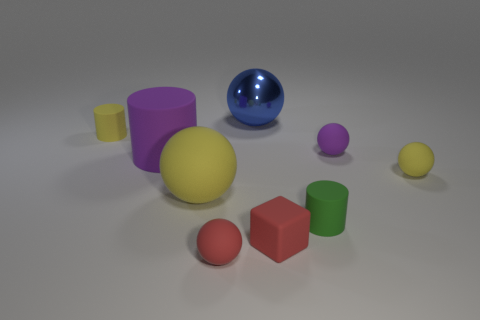There is a red cube that is made of the same material as the yellow cylinder; what size is it?
Offer a very short reply. Small. What is the size of the thing that is left of the small purple rubber sphere and to the right of the tiny red matte block?
Your response must be concise. Small. How big is the yellow rubber sphere behind the yellow matte sphere that is in front of the tiny yellow thing that is right of the green cylinder?
Your answer should be very brief. Small. Does the small matte sphere that is behind the big purple rubber thing have the same color as the large cylinder?
Make the answer very short. Yes. How many things are either purple things or yellow matte cylinders?
Offer a very short reply. 3. What is the color of the small cylinder that is on the left side of the small red sphere?
Offer a very short reply. Yellow. Is the number of purple matte things that are left of the small red matte ball less than the number of large yellow matte things?
Your answer should be very brief. No. The object that is the same color as the matte block is what size?
Your answer should be compact. Small. Is there anything else that is the same size as the rubber block?
Keep it short and to the point. Yes. Is the material of the small green thing the same as the large cylinder?
Your response must be concise. Yes. 